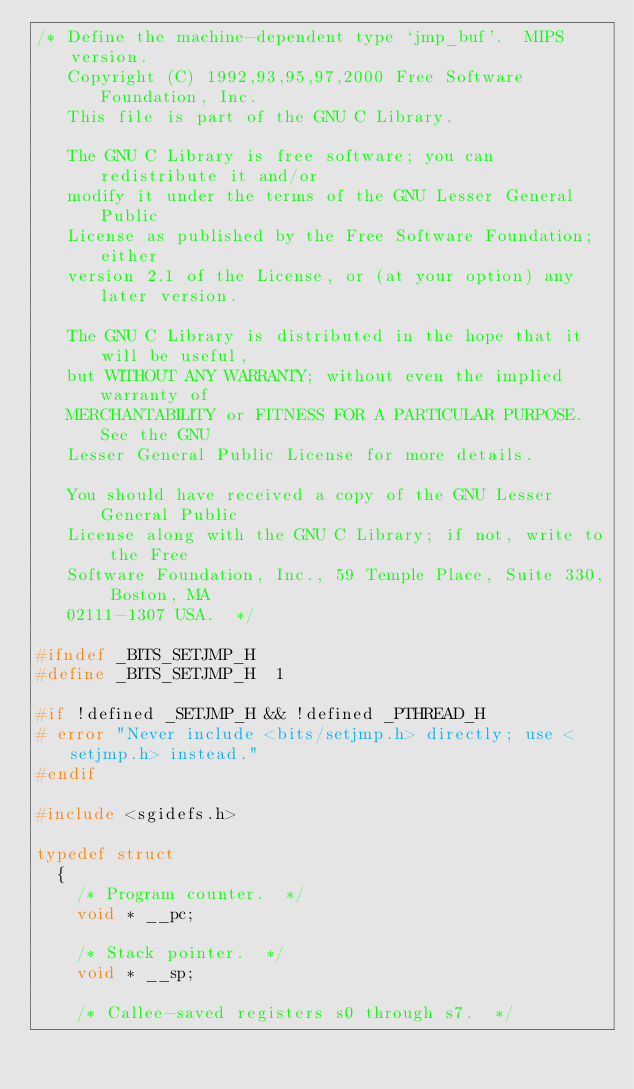Convert code to text. <code><loc_0><loc_0><loc_500><loc_500><_C_>/* Define the machine-dependent type `jmp_buf'.  MIPS version.
   Copyright (C) 1992,93,95,97,2000 Free Software Foundation, Inc.
   This file is part of the GNU C Library.

   The GNU C Library is free software; you can redistribute it and/or
   modify it under the terms of the GNU Lesser General Public
   License as published by the Free Software Foundation; either
   version 2.1 of the License, or (at your option) any later version.

   The GNU C Library is distributed in the hope that it will be useful,
   but WITHOUT ANY WARRANTY; without even the implied warranty of
   MERCHANTABILITY or FITNESS FOR A PARTICULAR PURPOSE.  See the GNU
   Lesser General Public License for more details.

   You should have received a copy of the GNU Lesser General Public
   License along with the GNU C Library; if not, write to the Free
   Software Foundation, Inc., 59 Temple Place, Suite 330, Boston, MA
   02111-1307 USA.  */

#ifndef _BITS_SETJMP_H
#define _BITS_SETJMP_H	1

#if !defined _SETJMP_H && !defined _PTHREAD_H
# error "Never include <bits/setjmp.h> directly; use <setjmp.h> instead."
#endif

#include <sgidefs.h>

typedef struct
  {
    /* Program counter.  */
    void * __pc;

    /* Stack pointer.  */
    void * __sp;

    /* Callee-saved registers s0 through s7.  */</code> 